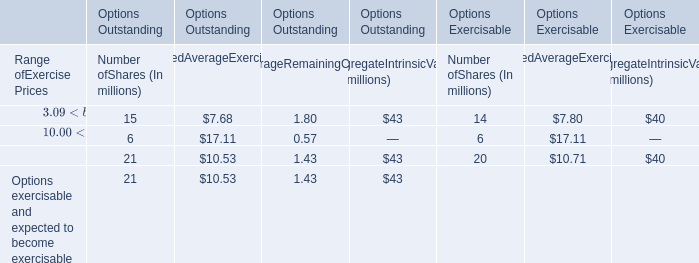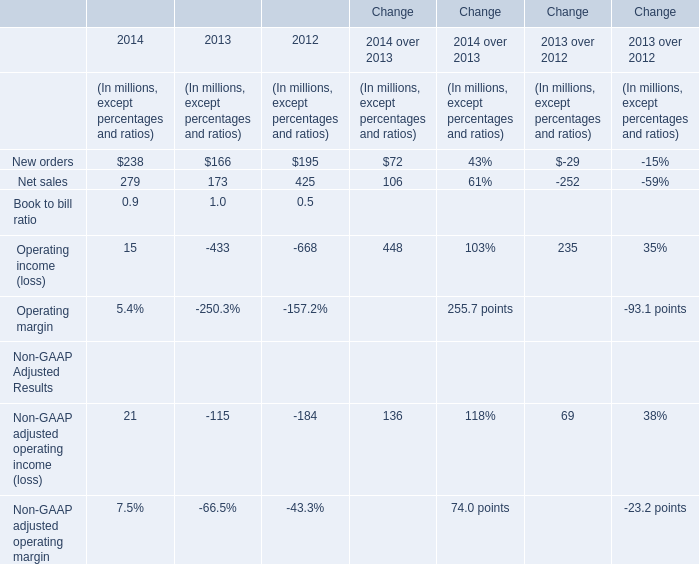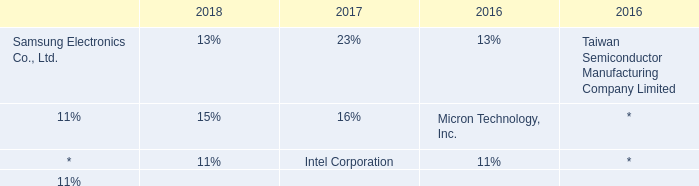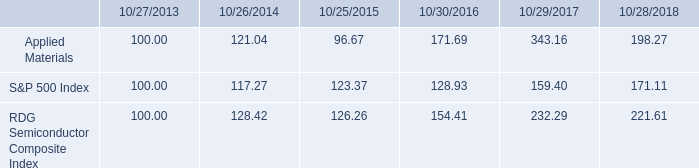what is the roi for applied materials if the investment made on october 2013 was sold 5 years later? 
Computations: ((198.27 - 100) / 100)
Answer: 0.9827. 